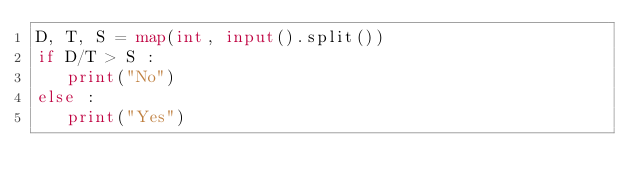<code> <loc_0><loc_0><loc_500><loc_500><_Python_>D, T, S = map(int, input().split())
if D/T > S : 
   print("No")
else : 
   print("Yes")
</code> 